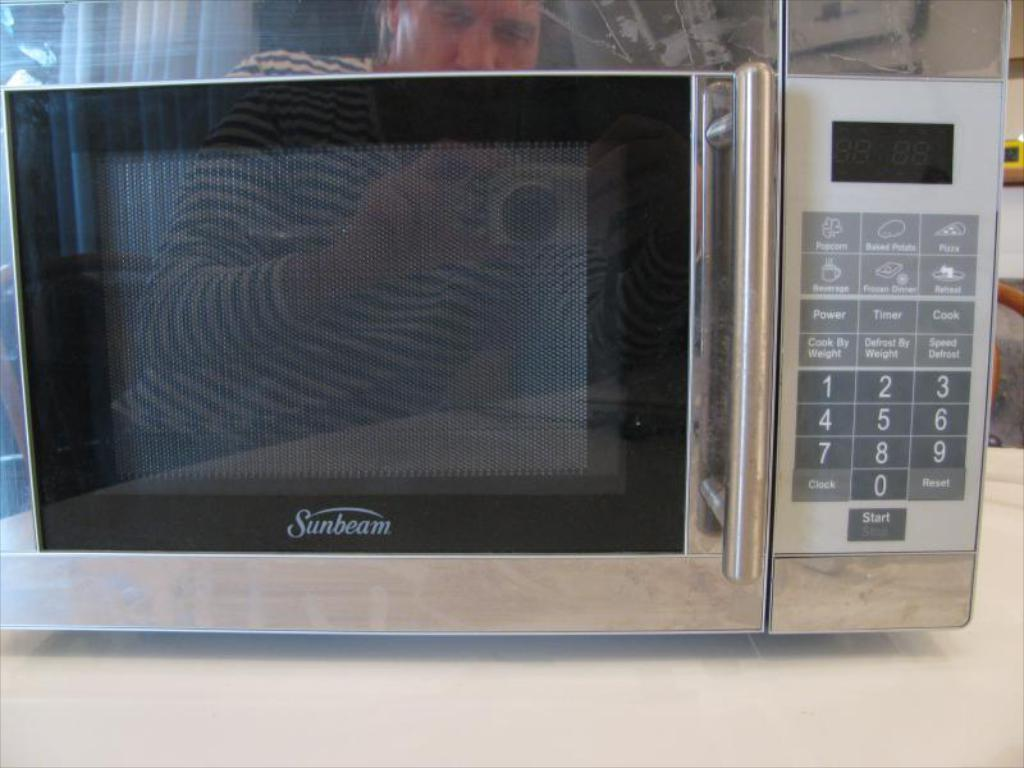<image>
Describe the image concisely. A stainless steel Sunbeam brand microwave placed on a countertop 